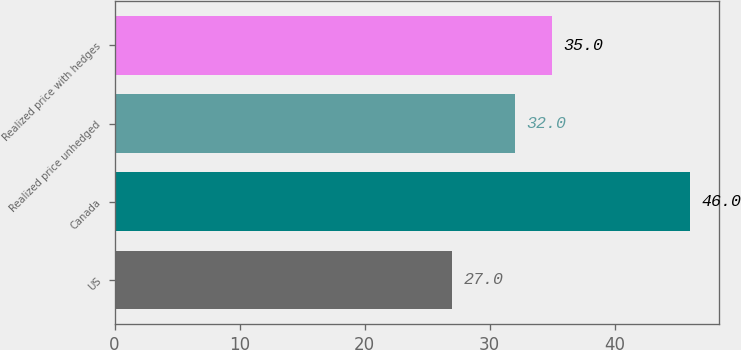Convert chart. <chart><loc_0><loc_0><loc_500><loc_500><bar_chart><fcel>US<fcel>Canada<fcel>Realized price unhedged<fcel>Realized price with hedges<nl><fcel>27<fcel>46<fcel>32<fcel>35<nl></chart> 